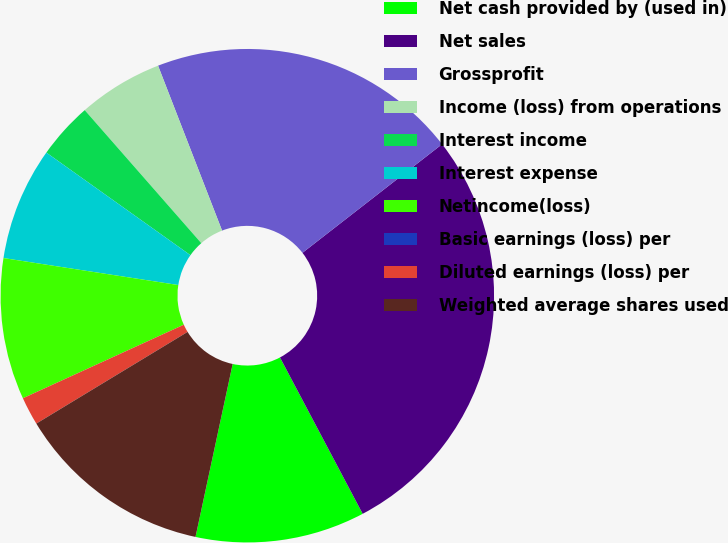<chart> <loc_0><loc_0><loc_500><loc_500><pie_chart><fcel>Net cash provided by (used in)<fcel>Net sales<fcel>Grossprofit<fcel>Income (loss) from operations<fcel>Interest income<fcel>Interest expense<fcel>Netincome(loss)<fcel>Basic earnings (loss) per<fcel>Diluted earnings (loss) per<fcel>Weighted average shares used<nl><fcel>11.11%<fcel>27.78%<fcel>20.37%<fcel>5.56%<fcel>3.7%<fcel>7.41%<fcel>9.26%<fcel>0.0%<fcel>1.85%<fcel>12.96%<nl></chart> 